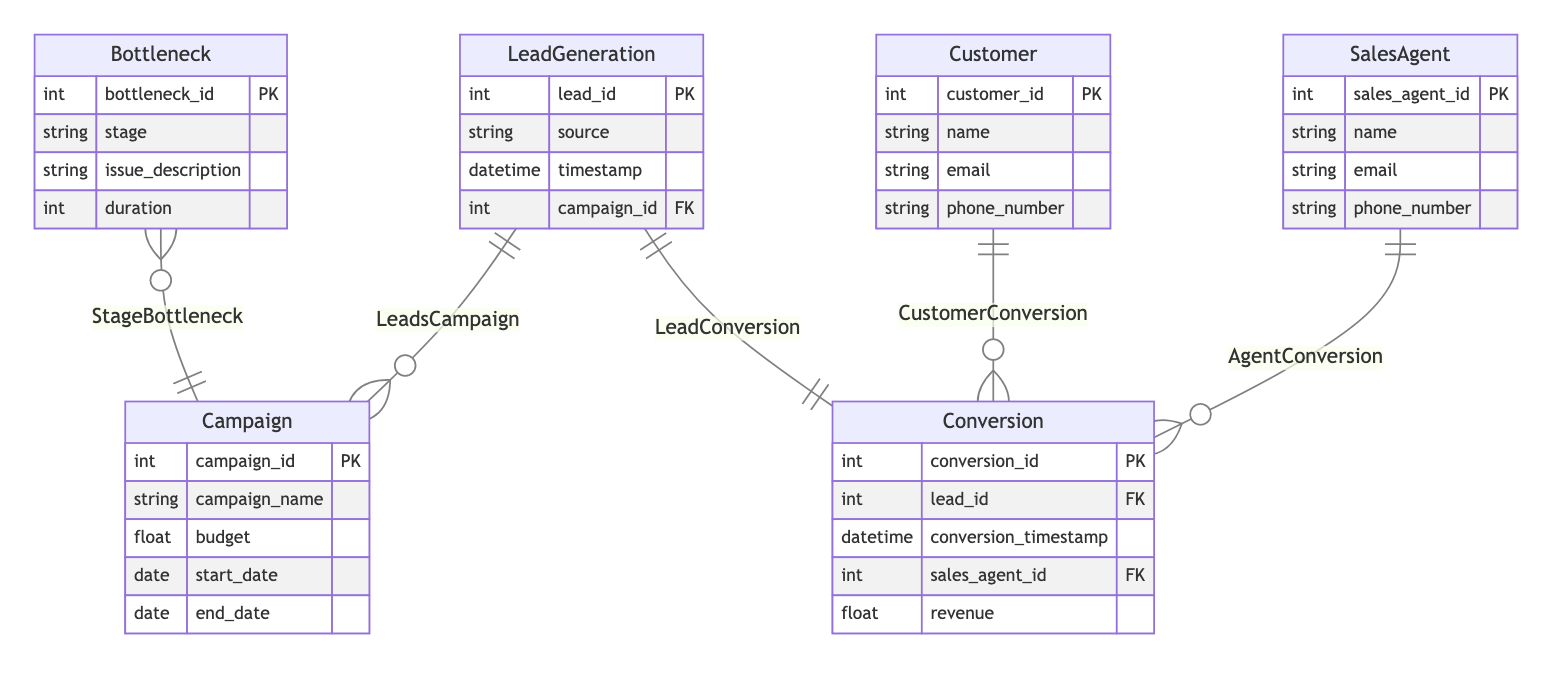what is the primary key of the LeadGeneration entity? The primary key for the LeadGeneration entity is lead_id, which uniquely identifies each lead in the database.
Answer: lead_id how many entities are present in the diagram? By counting the unique entities listed in the diagram, we find there are six: LeadGeneration, Campaign, Customer, Conversion, SalesAgent, and Bottleneck.
Answer: six which relationship connects LeadGeneration and Campaign? The relationship that connects these two entities is named "LeadsCampaign," indicating that multiple leads can be associated with one campaign.
Answer: LeadsCampaign what is the cardinality between Customer and Conversion? The relationship is One-to-Many, indicating that one customer can have multiple conversions associated with them, but each conversion is linked to only one customer.
Answer: One-to-Many how many attributes does the Campaign entity have? The Campaign entity has five attributes: campaign_id, campaign_name, budget, start_date, and end_date.
Answer: five what does the Bottleneck entity describe? The Bottleneck entity describes the issues occurring at various stages of a campaign, detailing specific problems that can impede conversion rates, represented with attributes like stage and duration.
Answer: issues which entity has a direct One-to-One relationship with LeadGeneration? The entity that has a One-to-One relationship with LeadGeneration is Conversion, meaning each lead corresponds to one and only one conversion event.
Answer: Conversion what is the foreign key in the Conversion entity? The foreign key in the Conversion entity is lead_id, which refers back to the LeadGeneration entity and links each conversion to its originating lead.
Answer: lead_id how many relationships involve the SalesAgent entity? There are two relationships involving the SalesAgent entity: one with the Conversion entity (AgentConversion) and one indirectly through the Customer entity.
Answer: two 